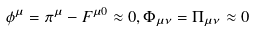Convert formula to latex. <formula><loc_0><loc_0><loc_500><loc_500>\phi ^ { \mu } = \pi ^ { \mu } - F ^ { \mu 0 } \approx 0 , \Phi _ { \mu \nu } = \Pi _ { \mu \nu } \approx 0</formula> 